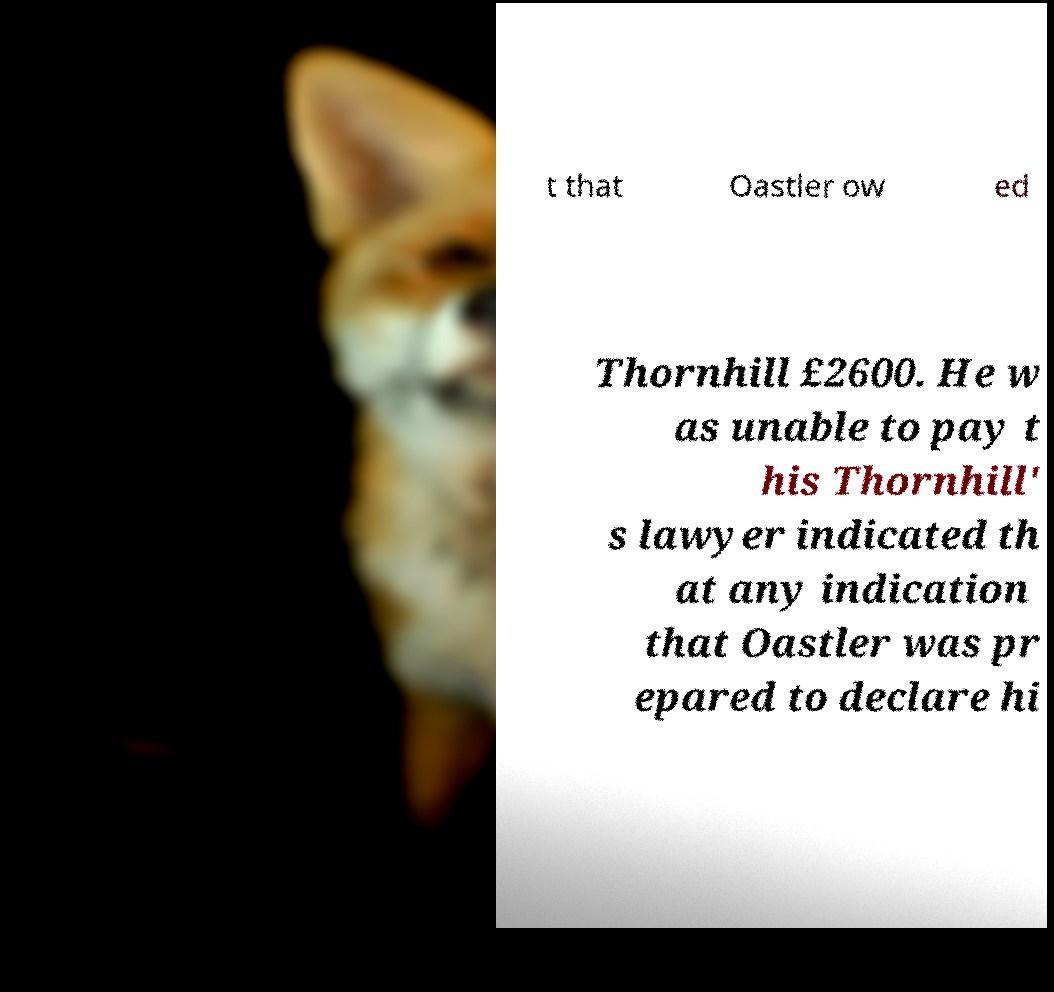Please read and relay the text visible in this image. What does it say? t that Oastler ow ed Thornhill £2600. He w as unable to pay t his Thornhill' s lawyer indicated th at any indication that Oastler was pr epared to declare hi 